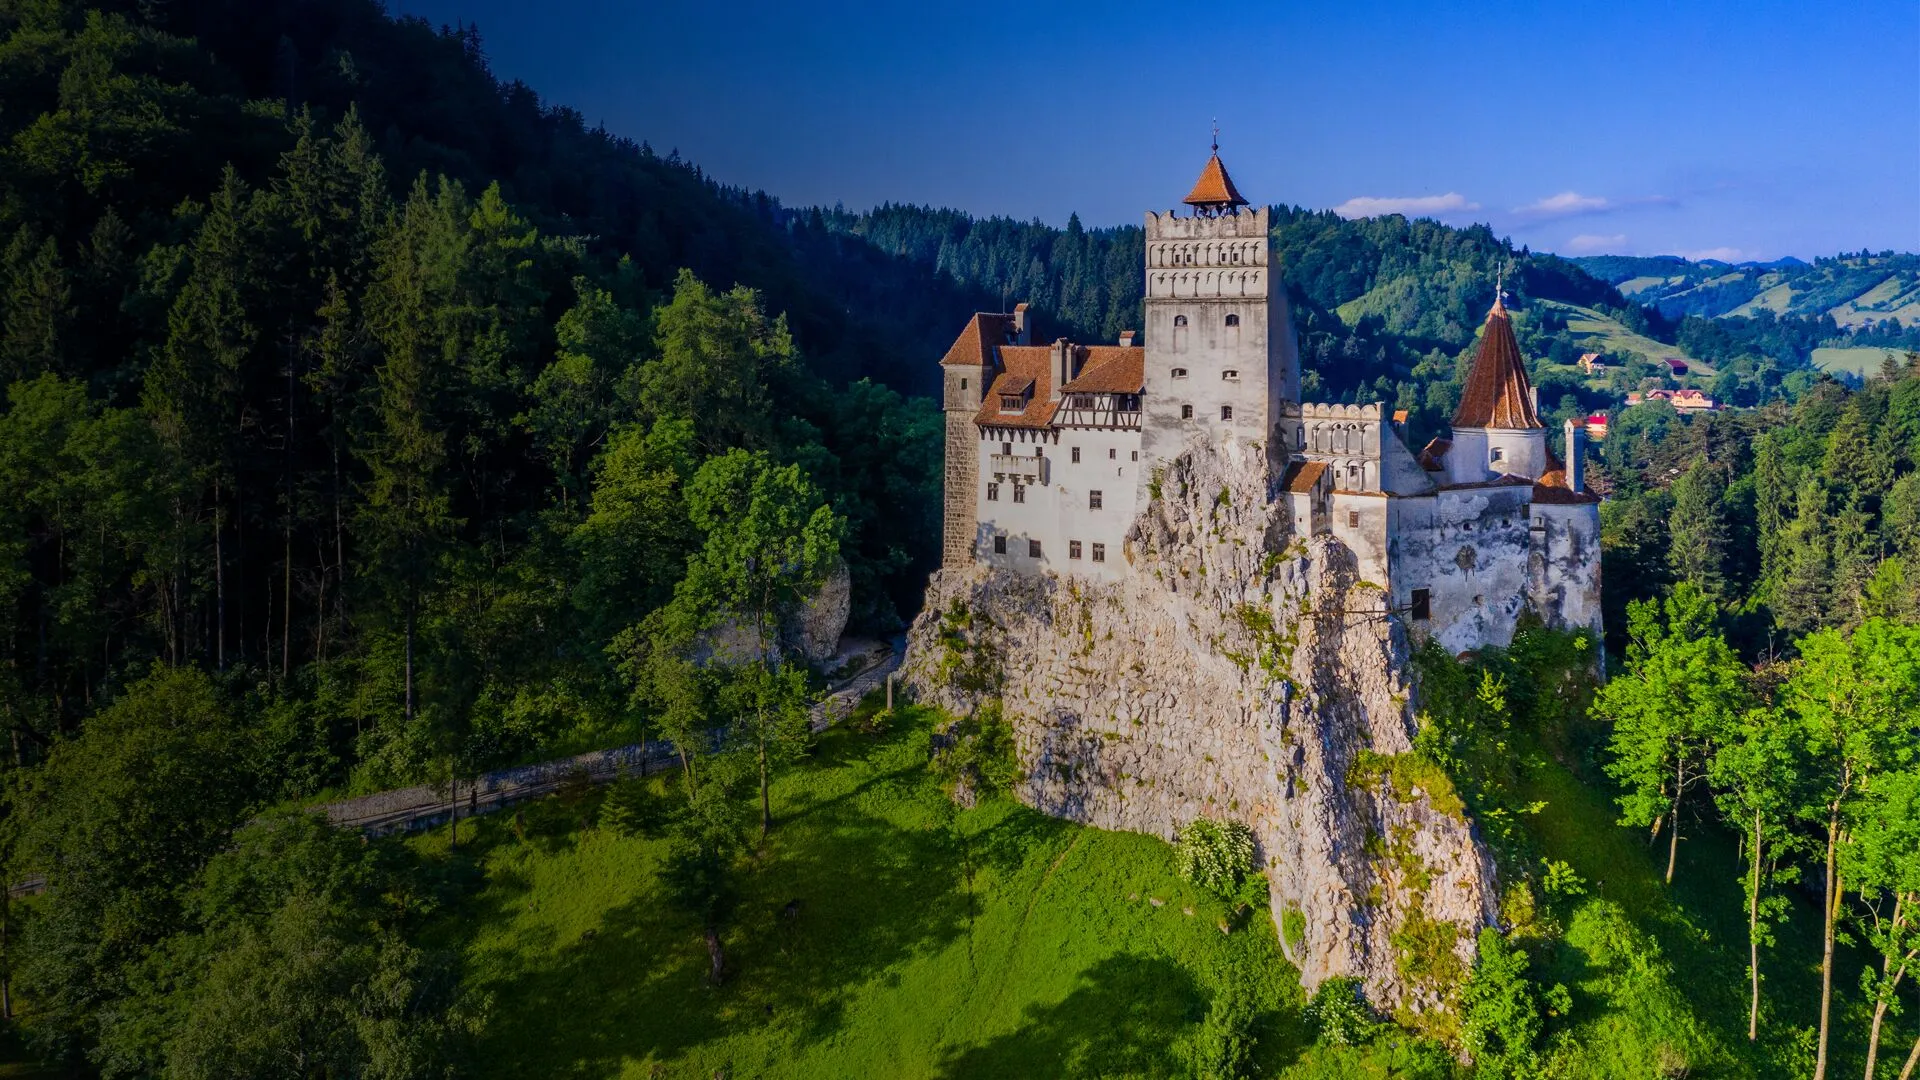What if the castle held a secret treasure, hidden for centuries, waiting to be discovered? Imagine that deep within the bowels of Bran Castle lies a hidden chamber, untouched by time and shrouded in mystery. This secret room, discovered only by solving a series of ancient riddles and navigating through winding, concealed passageways, holds a magnificent treasure. Intricately crafted chests brimming with gold coins, dazzling jewels, and artifacts from bygone eras are meticulously arranged around the room. Among the riches lies a legendary artifact – a golden scepter said to possess mystical powers, capable of altering the fate of whoever wields it. The air in the chamber is thick with the aura of legend and history, and as the first rays of light pierce through a hidden crevice, the treasures gleam, waiting for the day they will finally be discovered and their secrets unveiled. 